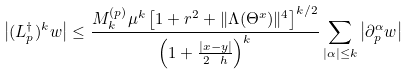Convert formula to latex. <formula><loc_0><loc_0><loc_500><loc_500>\left | ( L _ { p } ^ { \dagger } ) ^ { k } w \right | \leq \frac { M ^ { ( p ) } _ { k } \mu ^ { k } \left [ 1 + r ^ { 2 } + \| \Lambda ( \Theta ^ { x } ) \| ^ { 4 } \right ] ^ { k / 2 } } { \left ( 1 + \frac { | x - y | } { 2 \ h } \right ) ^ { k } } \sum _ { | \alpha | \leq k } \left | \partial _ { p } ^ { \alpha } w \right |</formula> 